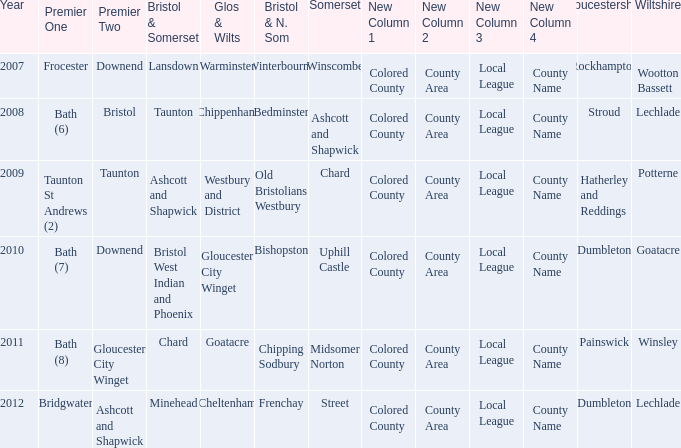What is the somerset for the  year 2009? Chard. 